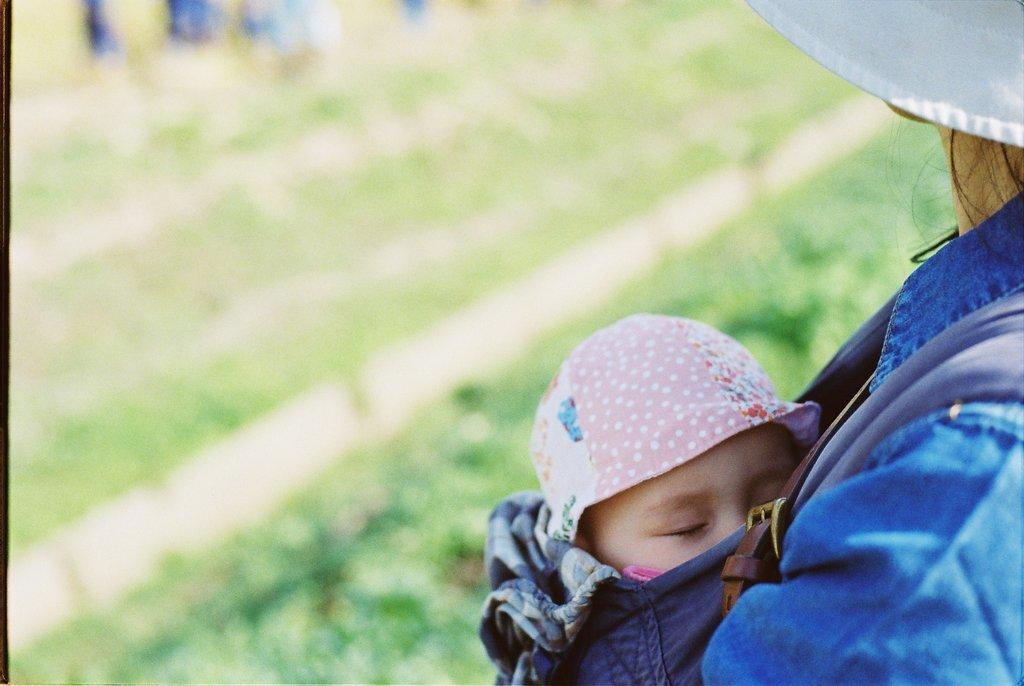Who is the person on the right side of the image? There is a person in a white hat and blue jacket on the right side of the image. What is the person holding? The person is holding a baby. What can be seen on the baby's head? The baby is wearing a pink cap. Can you describe the background of the image? The background of the image is blurred. What type of fish can be seen in the baby's nest in the image? There is no fish or nest present in the image; it features a person holding a baby with a pink cap. 